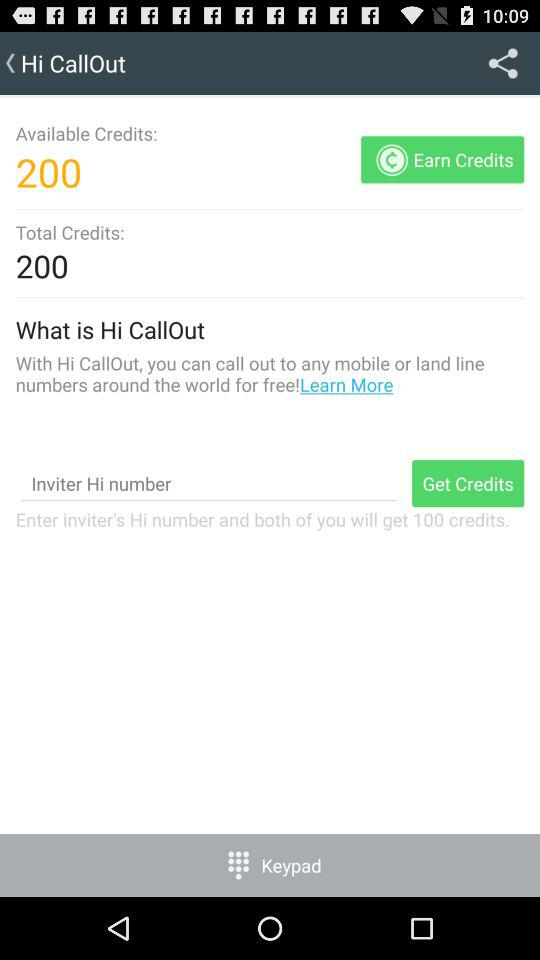What is the app name? The app name is "Hi CallOut". 